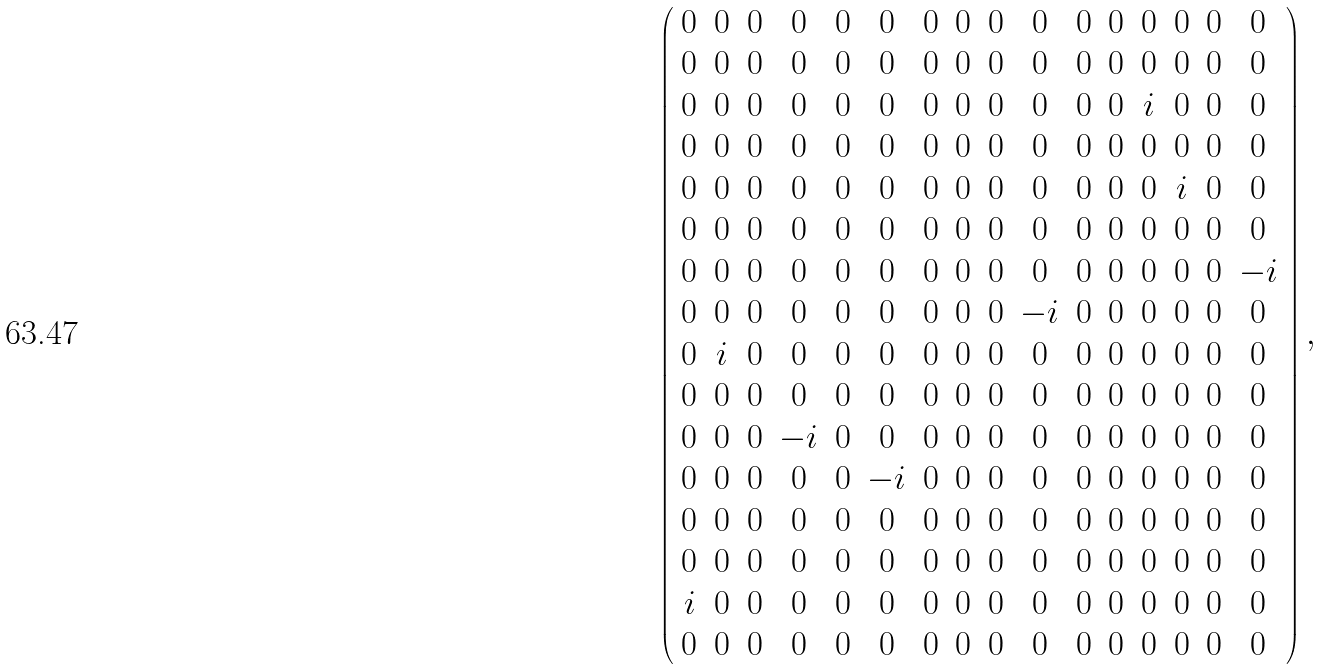Convert formula to latex. <formula><loc_0><loc_0><loc_500><loc_500>\left ( \begin{array} { c c c c c c c c c c c c c c c c } { 0 } & { 0 } & { 0 } & { 0 } & { 0 } & { 0 } & { 0 } & { 0 } & { 0 } & { 0 } & { 0 } & { 0 } & { 0 } & { 0 } & { 0 } & { 0 } \\ { 0 } & { 0 } & { 0 } & { 0 } & { 0 } & { 0 } & { 0 } & { 0 } & { 0 } & { 0 } & { 0 } & { 0 } & { 0 } & { 0 } & { 0 } & { 0 } \\ { 0 } & { 0 } & { 0 } & { 0 } & { 0 } & { 0 } & { 0 } & { 0 } & { 0 } & { 0 } & { 0 } & { 0 } & { i } & { 0 } & { 0 } & { 0 } \\ { 0 } & { 0 } & { 0 } & { 0 } & { 0 } & { 0 } & { 0 } & { 0 } & { 0 } & { 0 } & { 0 } & { 0 } & { 0 } & { 0 } & { 0 } & { 0 } \\ { 0 } & { 0 } & { 0 } & { 0 } & { 0 } & { 0 } & { 0 } & { 0 } & { 0 } & { 0 } & { 0 } & { 0 } & { 0 } & { i } & { 0 } & { 0 } \\ { 0 } & { 0 } & { 0 } & { 0 } & { 0 } & { 0 } & { 0 } & { 0 } & { 0 } & { 0 } & { 0 } & { 0 } & { 0 } & { 0 } & { 0 } & { 0 } \\ { 0 } & { 0 } & { 0 } & { 0 } & { 0 } & { 0 } & { 0 } & { 0 } & { 0 } & { 0 } & { 0 } & { 0 } & { 0 } & { 0 } & { 0 } & { - i } \\ { 0 } & { 0 } & { 0 } & { 0 } & { 0 } & { 0 } & { 0 } & { 0 } & { 0 } & { - i } & { 0 } & { 0 } & { 0 } & { 0 } & { 0 } & { 0 } \\ { 0 } & { i } & { 0 } & { 0 } & { 0 } & { 0 } & { 0 } & { 0 } & { 0 } & { 0 } & { 0 } & { 0 } & { 0 } & { 0 } & { 0 } & { 0 } \\ { 0 } & { 0 } & { 0 } & { 0 } & { 0 } & { 0 } & { 0 } & { 0 } & { 0 } & { 0 } & { 0 } & { 0 } & { 0 } & { 0 } & { 0 } & { 0 } \\ { 0 } & { 0 } & { 0 } & { - i } & { 0 } & { 0 } & { 0 } & { 0 } & { 0 } & { 0 } & { 0 } & { 0 } & { 0 } & { 0 } & { 0 } & { 0 } \\ { 0 } & { 0 } & { 0 } & { 0 } & { 0 } & { - i } & { 0 } & { 0 } & { 0 } & { 0 } & { 0 } & { 0 } & { 0 } & { 0 } & { 0 } & { 0 } \\ { 0 } & { 0 } & { 0 } & { 0 } & { 0 } & { 0 } & { 0 } & { 0 } & { 0 } & { 0 } & { 0 } & { 0 } & { 0 } & { 0 } & { 0 } & { 0 } \\ { 0 } & { 0 } & { 0 } & { 0 } & { 0 } & { 0 } & { 0 } & { 0 } & { 0 } & { 0 } & { 0 } & { 0 } & { 0 } & { 0 } & { 0 } & { 0 } \\ { i } & { 0 } & { 0 } & { 0 } & { 0 } & { 0 } & { 0 } & { 0 } & { 0 } & { 0 } & { 0 } & { 0 } & { 0 } & { 0 } & { 0 } & { 0 } \\ { 0 } & { 0 } & { 0 } & { 0 } & { 0 } & { 0 } & { 0 } & { 0 } & { 0 } & { 0 } & { 0 } & { 0 } & { 0 } & { 0 } & { 0 } & { 0 } \end{array} \right ) ,</formula> 